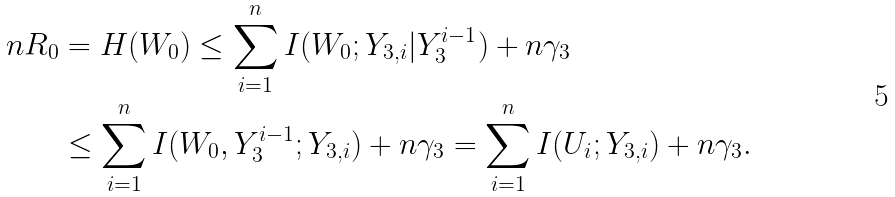<formula> <loc_0><loc_0><loc_500><loc_500>n R _ { 0 } & = H ( W _ { 0 } ) \leq \sum _ { i = 1 } ^ { n } I ( W _ { 0 } ; Y _ { 3 , i } | Y _ { 3 } ^ { i - 1 } ) + n \gamma _ { 3 } \\ & \leq \sum _ { i = 1 } ^ { n } I ( W _ { 0 } , Y _ { 3 } ^ { i - 1 } ; Y _ { 3 , i } ) + n \gamma _ { 3 } = \sum _ { i = 1 } ^ { n } I ( U _ { i } ; Y _ { 3 , i } ) + n \gamma _ { 3 } .</formula> 